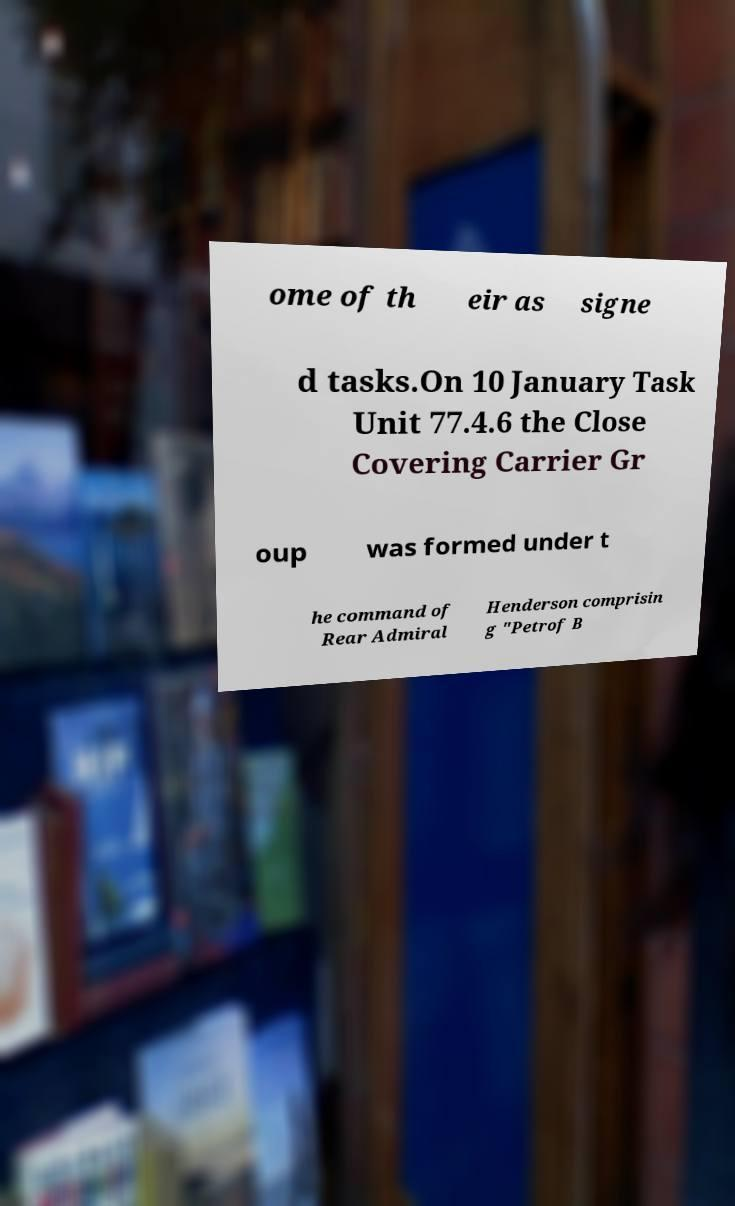What messages or text are displayed in this image? I need them in a readable, typed format. ome of th eir as signe d tasks.On 10 January Task Unit 77.4.6 the Close Covering Carrier Gr oup was formed under t he command of Rear Admiral Henderson comprisin g "Petrof B 